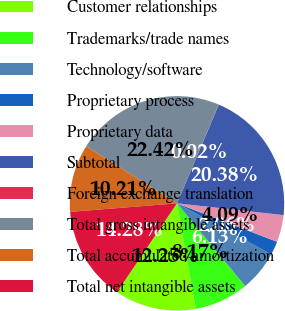Convert chart. <chart><loc_0><loc_0><loc_500><loc_500><pie_chart><fcel>Customer relationships<fcel>Trademarks/trade names<fcel>Technology/software<fcel>Proprietary process<fcel>Proprietary data<fcel>Subtotal<fcel>Foreign exchange translation<fcel>Total gross intangible assets<fcel>Total accumulated amortization<fcel>Total net intangible assets<nl><fcel>12.25%<fcel>8.17%<fcel>6.13%<fcel>2.06%<fcel>4.09%<fcel>20.38%<fcel>0.02%<fcel>22.42%<fcel>10.21%<fcel>14.28%<nl></chart> 